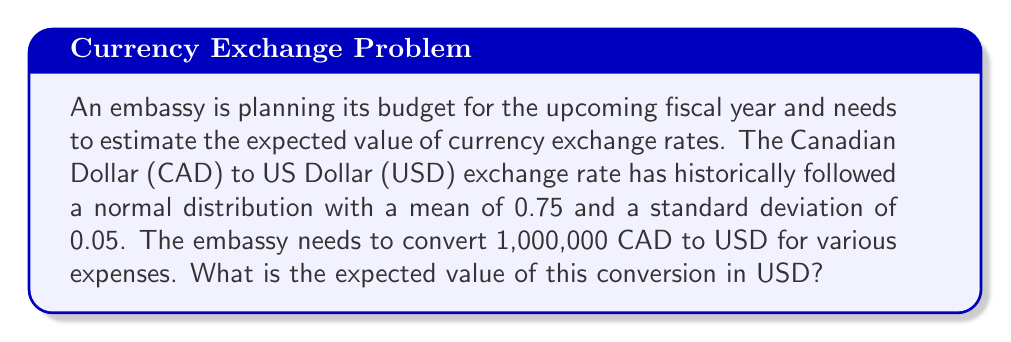Help me with this question. To solve this problem, we'll follow these steps:

1) Recall that the expected value of a normal distribution is equal to its mean.

2) The mean of the CAD to USD exchange rate is given as 0.75.

3) The amount to be converted is 1,000,000 CAD.

4) To calculate the expected value in USD, we multiply the amount in CAD by the expected exchange rate:

   $$E[\text{USD}] = \text{CAD} \times E[\text{exchange rate}]$$
   $$E[\text{USD}] = 1,000,000 \times 0.75$$
   $$E[\text{USD}] = 750,000$$

5) Therefore, the expected value of the conversion is 750,000 USD.

Note: The standard deviation doesn't affect the expected value calculation, but it would be relevant if we were calculating probabilities or confidence intervals for the exchange rate.
Answer: $750,000 USD 